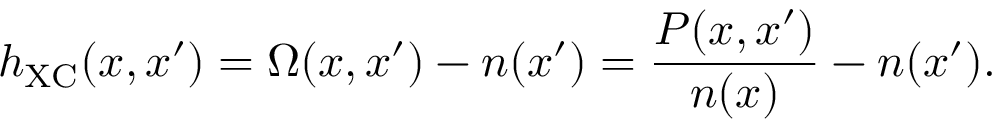<formula> <loc_0><loc_0><loc_500><loc_500>h _ { X C } ( x , x ^ { \prime } ) = \Omega ( x , x ^ { \prime } ) - n ( x ^ { \prime } ) = \frac { P ( x , x ^ { \prime } ) } { n ( x ) } - n ( x ^ { \prime } ) .</formula> 